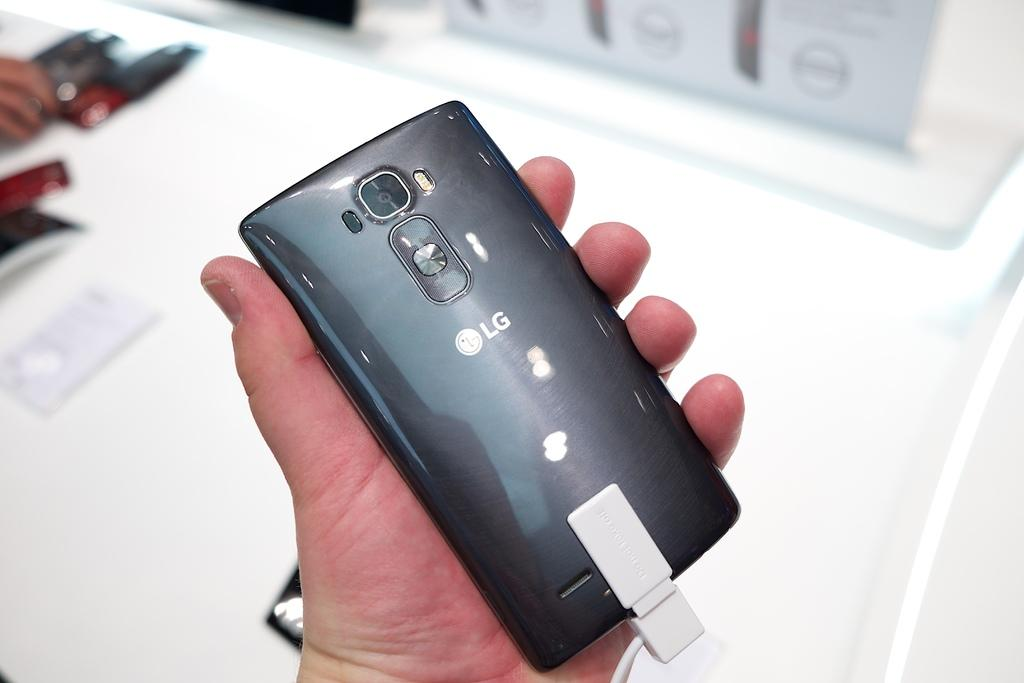Provide a one-sentence caption for the provided image. A person holding a LG phone in their left hand. 